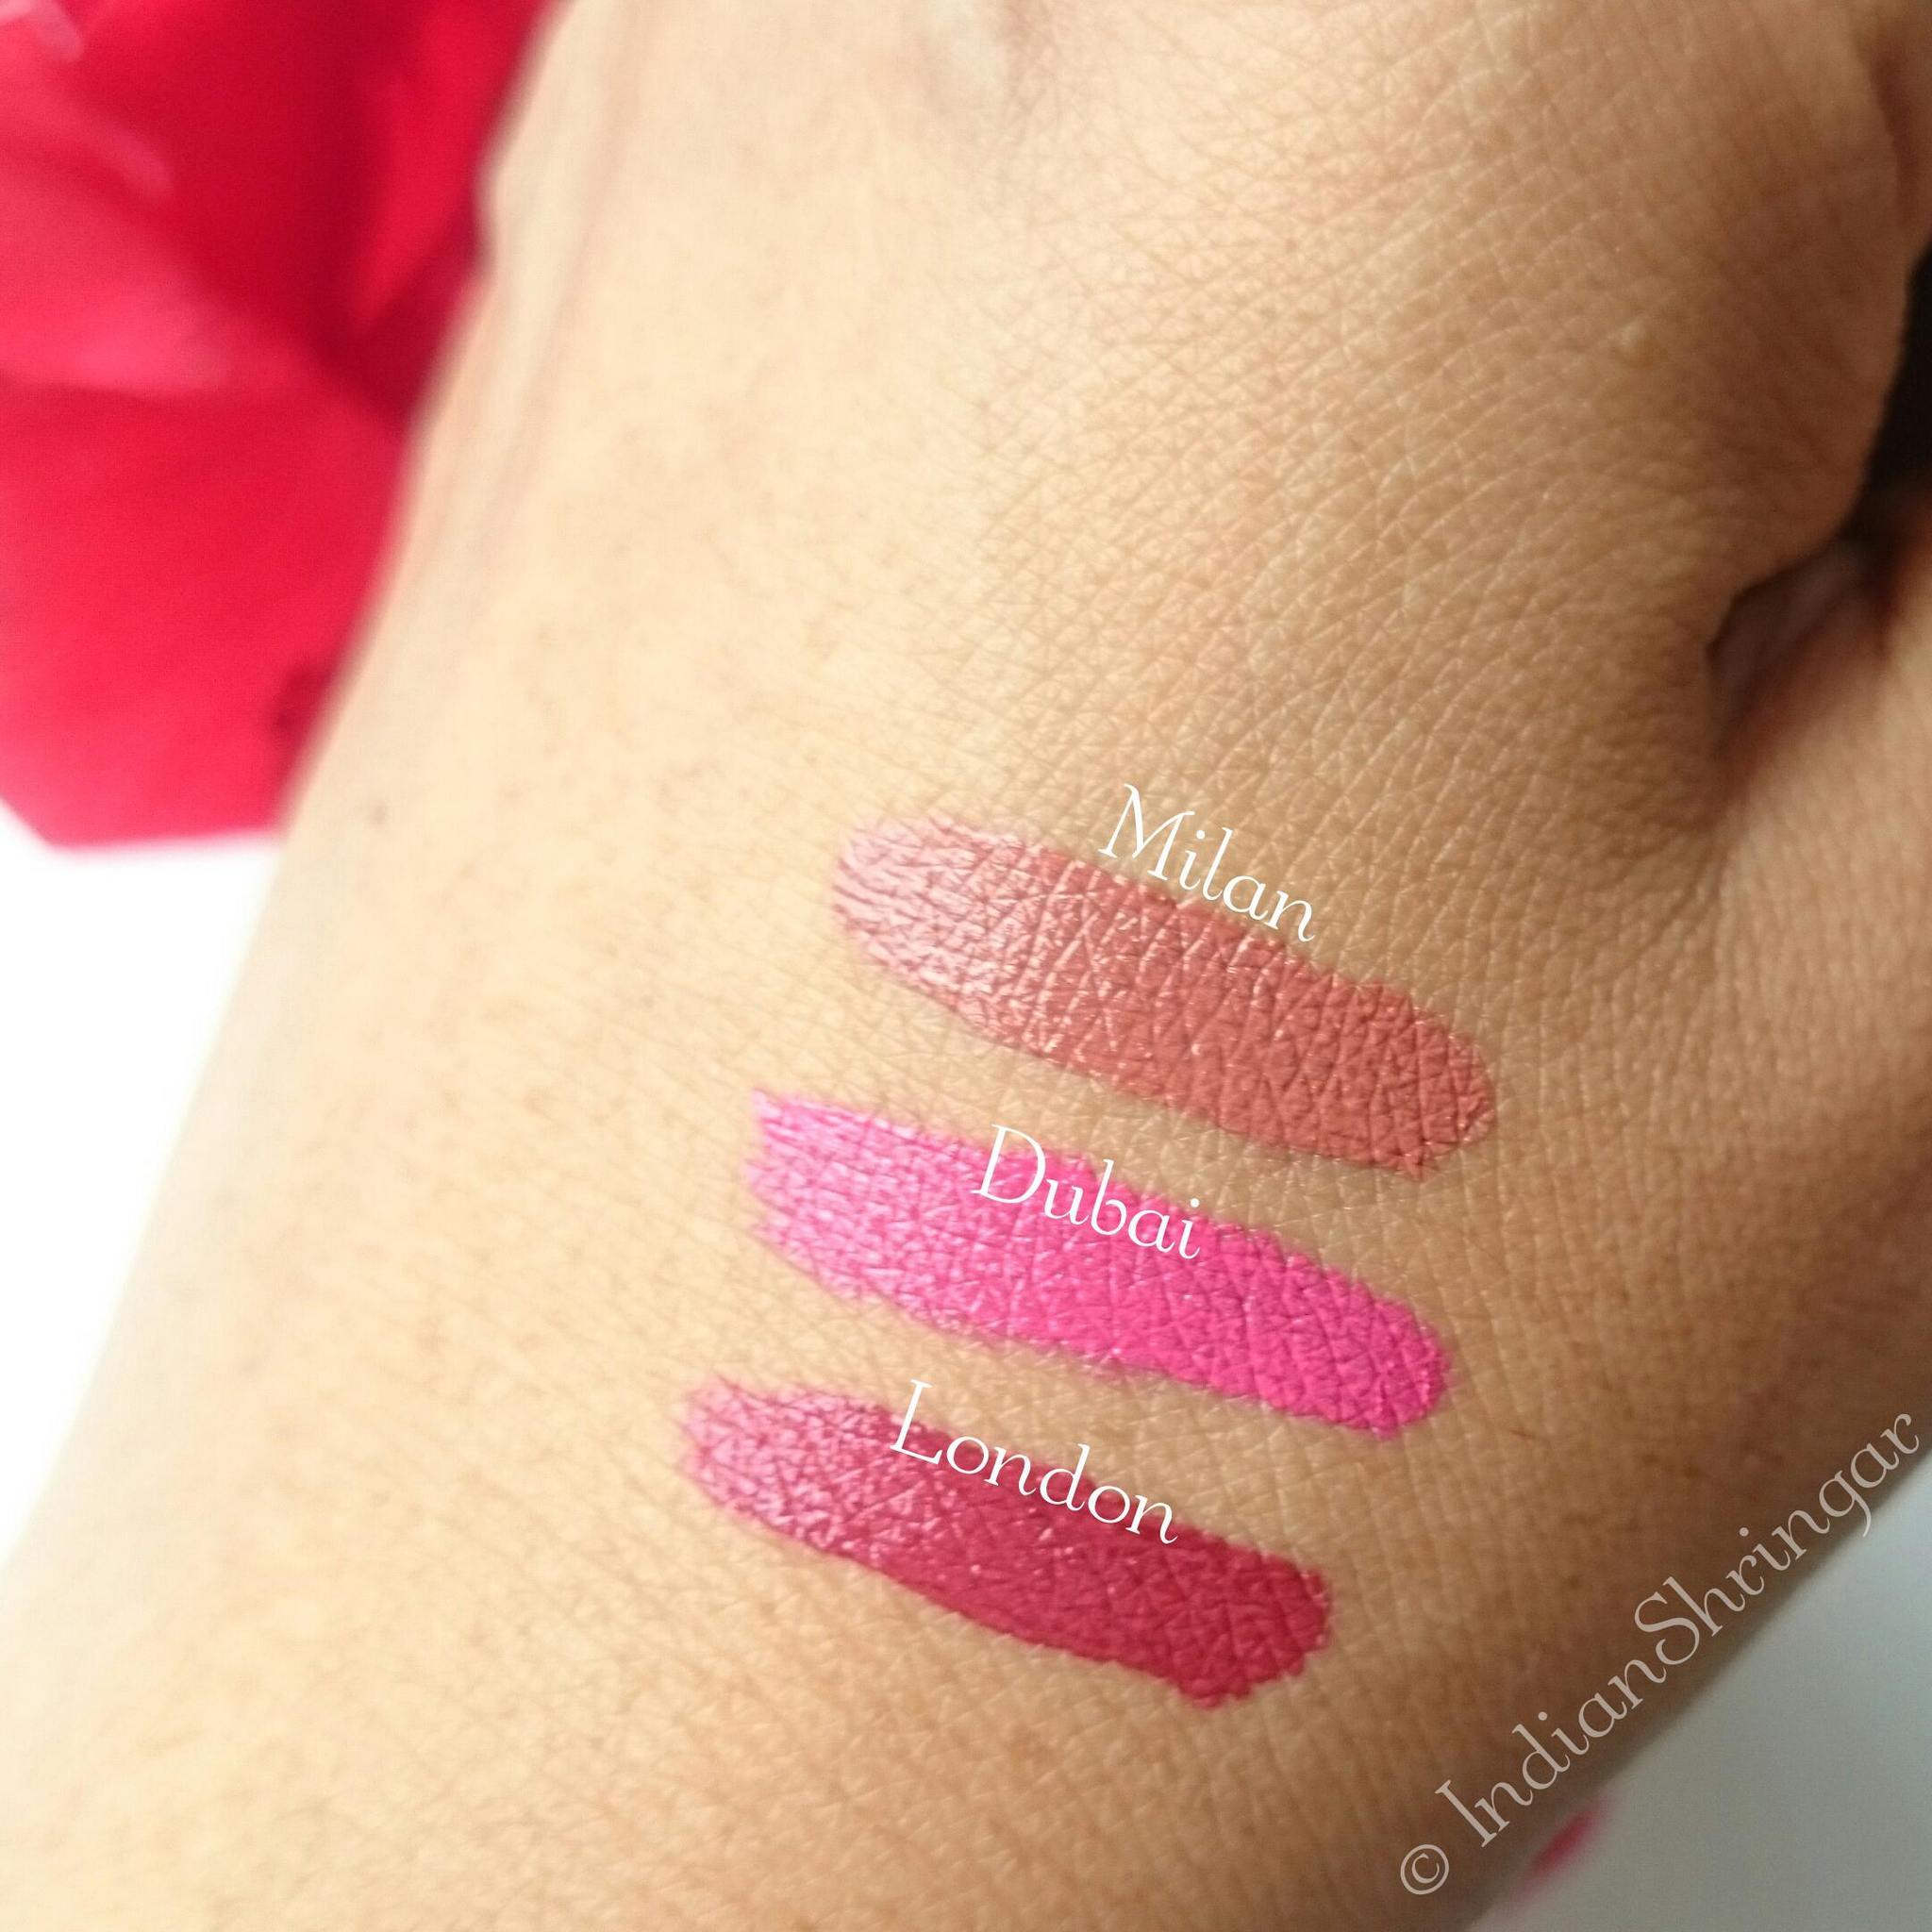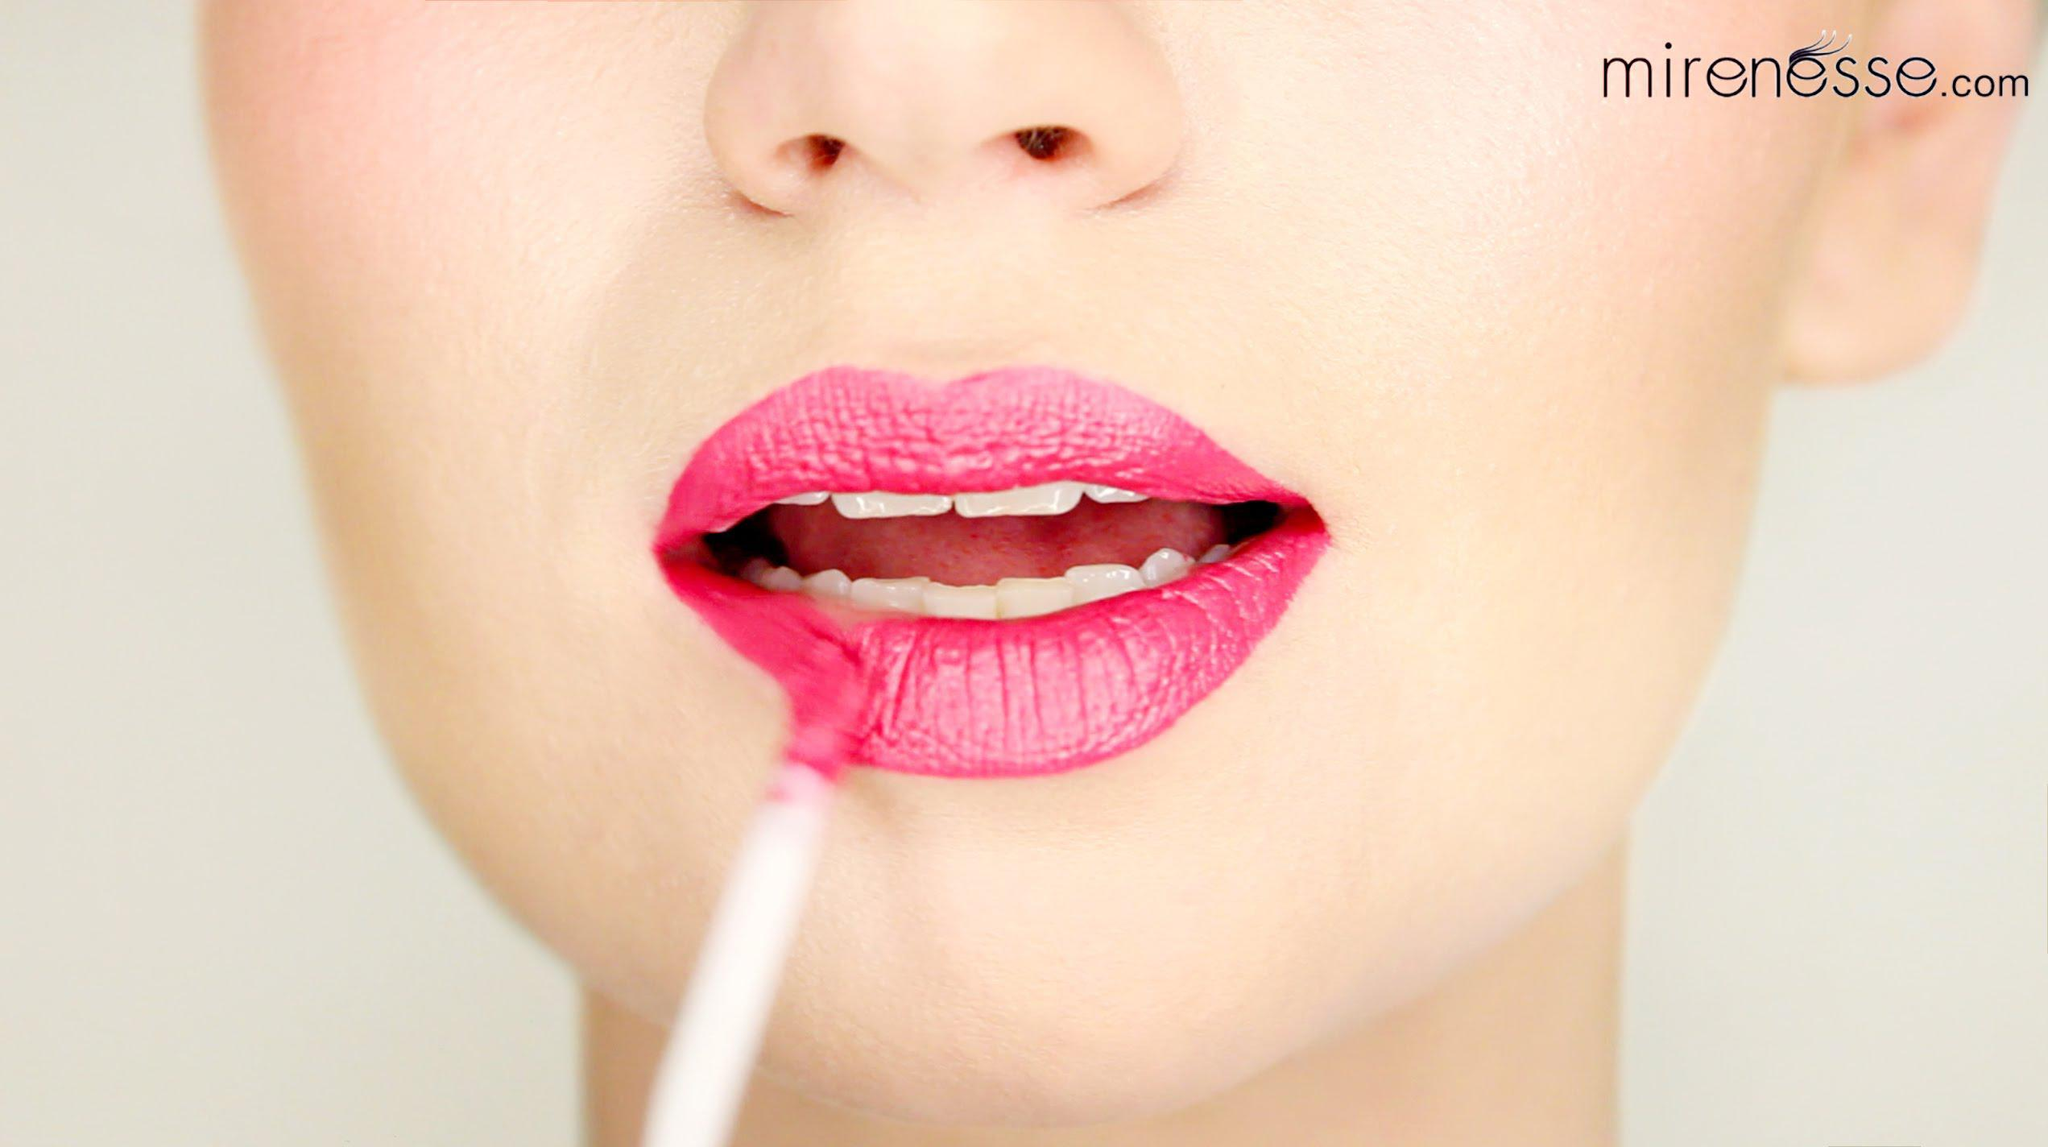The first image is the image on the left, the second image is the image on the right. Analyze the images presented: Is the assertion "There are no tinted lips in the left image only." valid? Answer yes or no. Yes. 